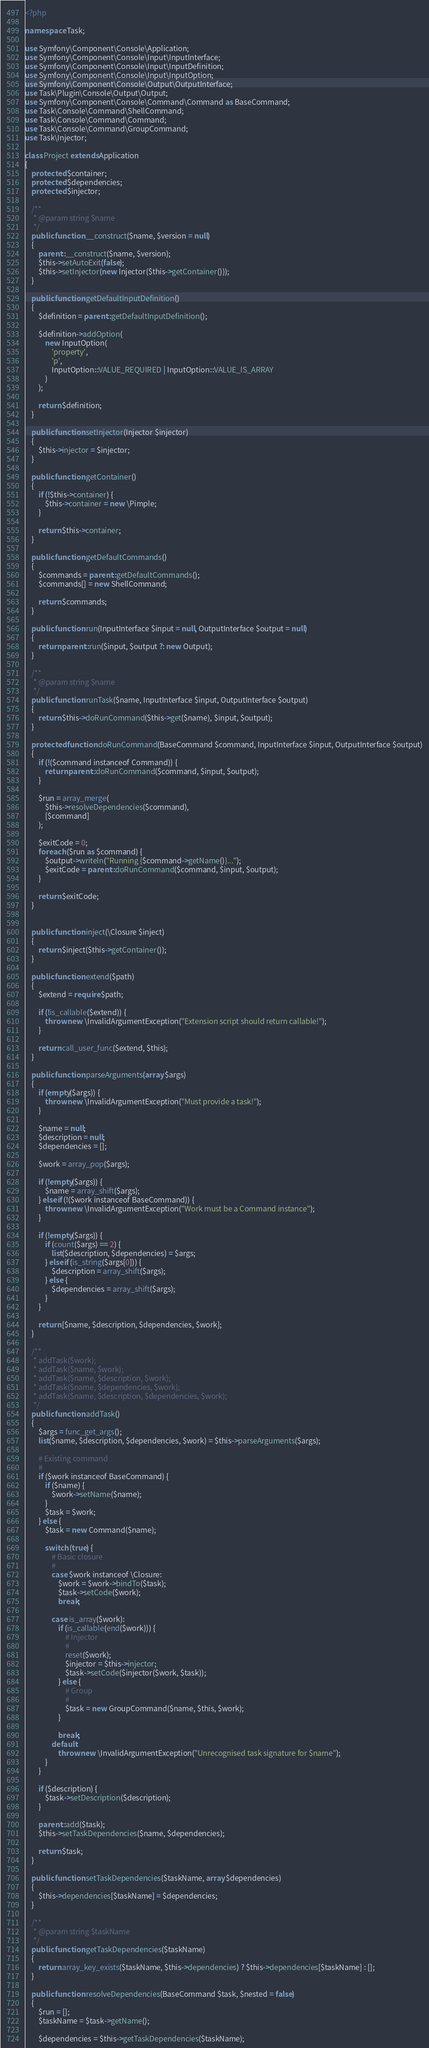Convert code to text. <code><loc_0><loc_0><loc_500><loc_500><_PHP_><?php

namespace Task;

use Symfony\Component\Console\Application;
use Symfony\Component\Console\Input\InputInterface;
use Symfony\Component\Console\Input\InputDefinition;
use Symfony\Component\Console\Input\InputOption;
use Symfony\Component\Console\Output\OutputInterface;
use Task\Plugin\Console\Output\Output;
use Symfony\Component\Console\Command\Command as BaseCommand;
use Task\Console\Command\ShellCommand;
use Task\Console\Command\Command;
use Task\Console\Command\GroupCommand;
use Task\Injector;

class Project extends Application
{
    protected $container;
    protected $dependencies;
    protected $injector;

    /**
     * @param string $name
     */
    public function __construct($name, $version = null)
    {
        parent::__construct($name, $version);
        $this->setAutoExit(false);
        $this->setInjector(new Injector($this->getContainer()));
    }

    public function getDefaultInputDefinition()
    {
        $definition = parent::getDefaultInputDefinition();

        $definition->addOption(
            new InputOption(
                'property',
                'p',
                InputOption::VALUE_REQUIRED | InputOption::VALUE_IS_ARRAY
            )
        );

        return $definition;
    }

    public function setInjector(Injector $injector)
    {
        $this->injector = $injector;
    }

    public function getContainer()
    {
        if (!$this->container) {
            $this->container = new \Pimple;
        }

        return $this->container;
    }

    public function getDefaultCommands()
    {
        $commands = parent::getDefaultCommands();
        $commands[] = new ShellCommand;

        return $commands;
    }

    public function run(InputInterface $input = null, OutputInterface $output = null)
    {
        return parent::run($input, $output ?: new Output);
    }

    /**
     * @param string $name
     */
    public function runTask($name, InputInterface $input, OutputInterface $output)
    {
        return $this->doRunCommand($this->get($name), $input, $output);
    }

    protected function doRunCommand(BaseCommand $command, InputInterface $input, OutputInterface $output)
    {
        if (!($command instanceof Command)) {
            return parent::doRunCommand($command, $input, $output);
        }

        $run = array_merge(
            $this->resolveDependencies($command),
            [$command]
        );

        $exitCode = 0;
        foreach ($run as $command) {
            $output->writeln("Running {$command->getName()}...");
            $exitCode = parent::doRunCommand($command, $input, $output);
        }

        return $exitCode;
    }


    public function inject(\Closure $inject)
    {
        return $inject($this->getContainer());
    }

    public function extend($path)
    {
        $extend = require $path;

        if (!is_callable($extend)) {
            throw new \InvalidArgumentException("Extension script should return callable!");
        }

        return call_user_func($extend, $this);
    }

    public function parseArguments(array $args)
    {
        if (empty($args)) {
            throw new \InvalidArgumentException("Must provide a task!");
        }

        $name = null;
        $description = null;
        $dependencies = [];

        $work = array_pop($args);

        if (!empty($args)) {
            $name = array_shift($args);
        } elseif (!($work instanceof BaseCommand)) {
            throw new \InvalidArgumentException("Work must be a Command instance");
        }

        if (!empty($args)) {
            if (count($args) == 2) {
                list($description, $dependencies) = $args;
            } elseif (is_string($args[0])) {
                $description = array_shift($args);
            } else {
                $dependencies = array_shift($args);
            }
        }

        return [$name, $description, $dependencies, $work];
    }

    /**
     * addTask($work);
     * addTask($name, $work);
     * addTask($name, $description, $work);
     * addTask($name, $dependencies, $work);
     * addTask($name, $description, $dependencies, $work);
     */
    public function addTask()
    {
        $args = func_get_args();
        list($name, $description, $dependencies, $work) = $this->parseArguments($args);

        # Existing command
        #
        if ($work instanceof BaseCommand) {
            if ($name) {
                $work->setName($name);
            }
            $task = $work;
        } else {
            $task = new Command($name);

            switch (true) {
                # Basic closure
                #
                case $work instanceof \Closure:
                    $work = $work->bindTo($task);
                    $task->setCode($work);
                    break;

                case is_array($work):
                    if (is_callable(end($work))) {
                        # Injector
                        #
                        reset($work);
                        $injector = $this->injector;
                        $task->setCode($injector($work, $task));
                    } else {
                        # Group
                        #
                        $task = new GroupCommand($name, $this, $work);
                    }

                    break;
                default:
                    throw new \InvalidArgumentException("Unrecognised task signature for $name");
            }
        }

        if ($description) {
            $task->setDescription($description);
        }

        parent::add($task);
        $this->setTaskDependencies($name, $dependencies);

        return $task;
    }

    public function setTaskDependencies($taskName, array $dependencies)
    {
        $this->dependencies[$taskName] = $dependencies;
    }

    /**
     * @param string $taskName
     */
    public function getTaskDependencies($taskName)
    {
        return array_key_exists($taskName, $this->dependencies) ? $this->dependencies[$taskName] : [];
    }

    public function resolveDependencies(BaseCommand $task, $nested = false)
    {
        $run = [];
        $taskName = $task->getName();

        $dependencies = $this->getTaskDependencies($taskName);</code> 